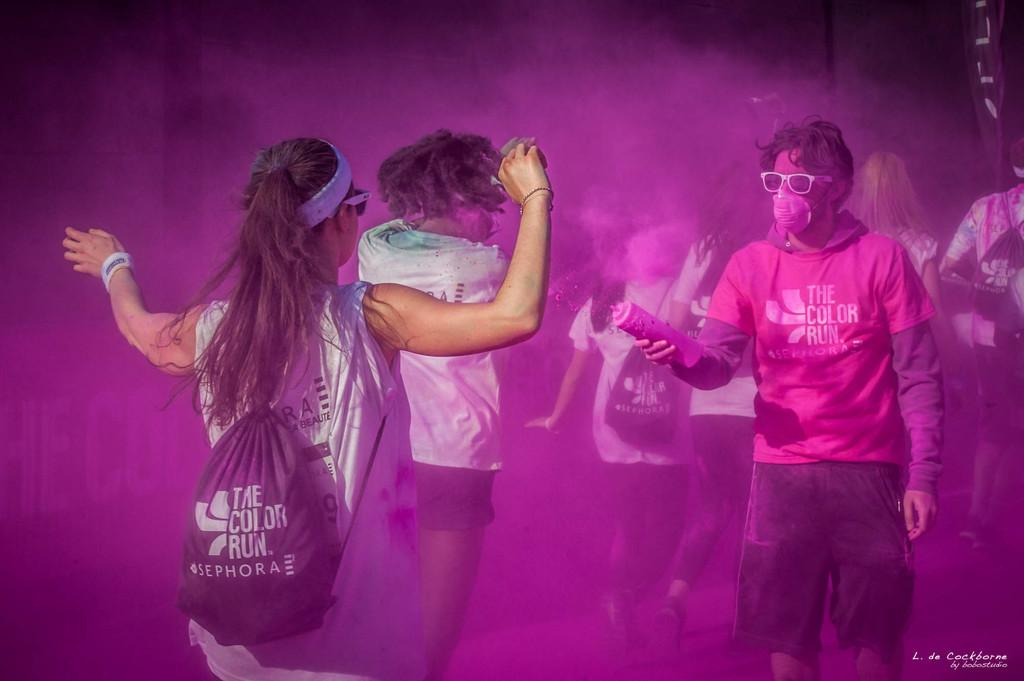How many people are in the main group in the image? There are three persons in the middle of the image. What is one of the persons wearing? One of the persons is wearing a bag. What is another person holding in their hand? Another person is holding a bottle in their hand. Can you describe the background of the image? There are additional persons visible in the background of the image. What type of business is being conducted in the hospital in the image? There is no hospital or business present in the image; it features three persons in the middle of the image. What is the nose of the person in the image doing? There is no specific information about the nose of any person in the image, as the facts provided do not mention noses. 